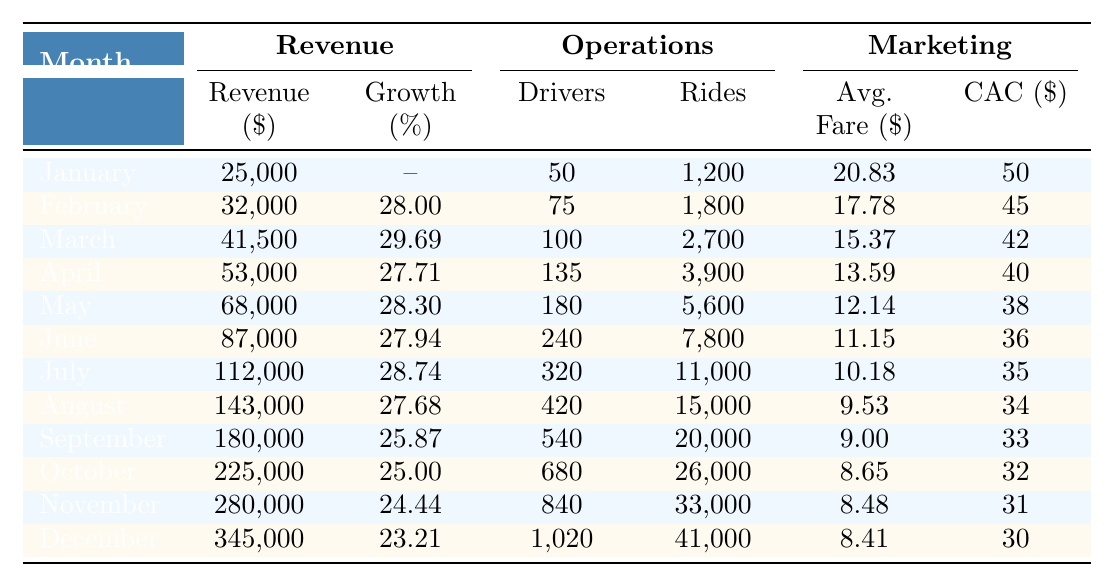What was the revenue in August? The table shows that the revenue for August is listed as 143,000.
Answer: 143,000 What was the growth rate in March? The growth rate for March is specified in the table as 29.69%.
Answer: 29.69% How many active drivers were there in December? The table indicates that there were 1,020 active drivers in December.
Answer: 1,020 Is the average fare in November higher than in October? The average fare in November is 8.48, which is less than October's average fare of 8.65, so the statement is false.
Answer: No What is the total number of completed rides from January to June? To find the total completed rides from January to June, I sum the data points: 1,200 + 1,800 + 2,700 + 3,900 + 5,600 + 7,800 = 22,000.
Answer: 22,000 What is the difference between the revenue in January and the revenue in December? The revenue in January is 25,000, and in December it is 345,000. The difference is 345,000 - 25,000 = 320,000.
Answer: 320,000 Which month had the highest growth rate? The table shows that July had the highest growth rate of 28.74% compared to all other months noted.
Answer: July What was the average customer acquisition cost across the entire year? To find the average, sum the costs: 50 + 45 + 42 + 40 + 38 + 36 + 35 + 34 + 33 + 32 + 31 + 30 =  501, then divide by 12: 501 / 12 = 41.75.
Answer: 41.75 How many completed rides increased from July to December? The completed rides in July are 11,000 and in December are 41,000. The increase is 41,000 - 11,000 = 30,000.
Answer: 30,000 Is the growth rate in April higher than in May? The growth rate for April is 27.71% and for May is 28.30%. Since 27.71% is less than 28.30%, the statement is false.
Answer: No 